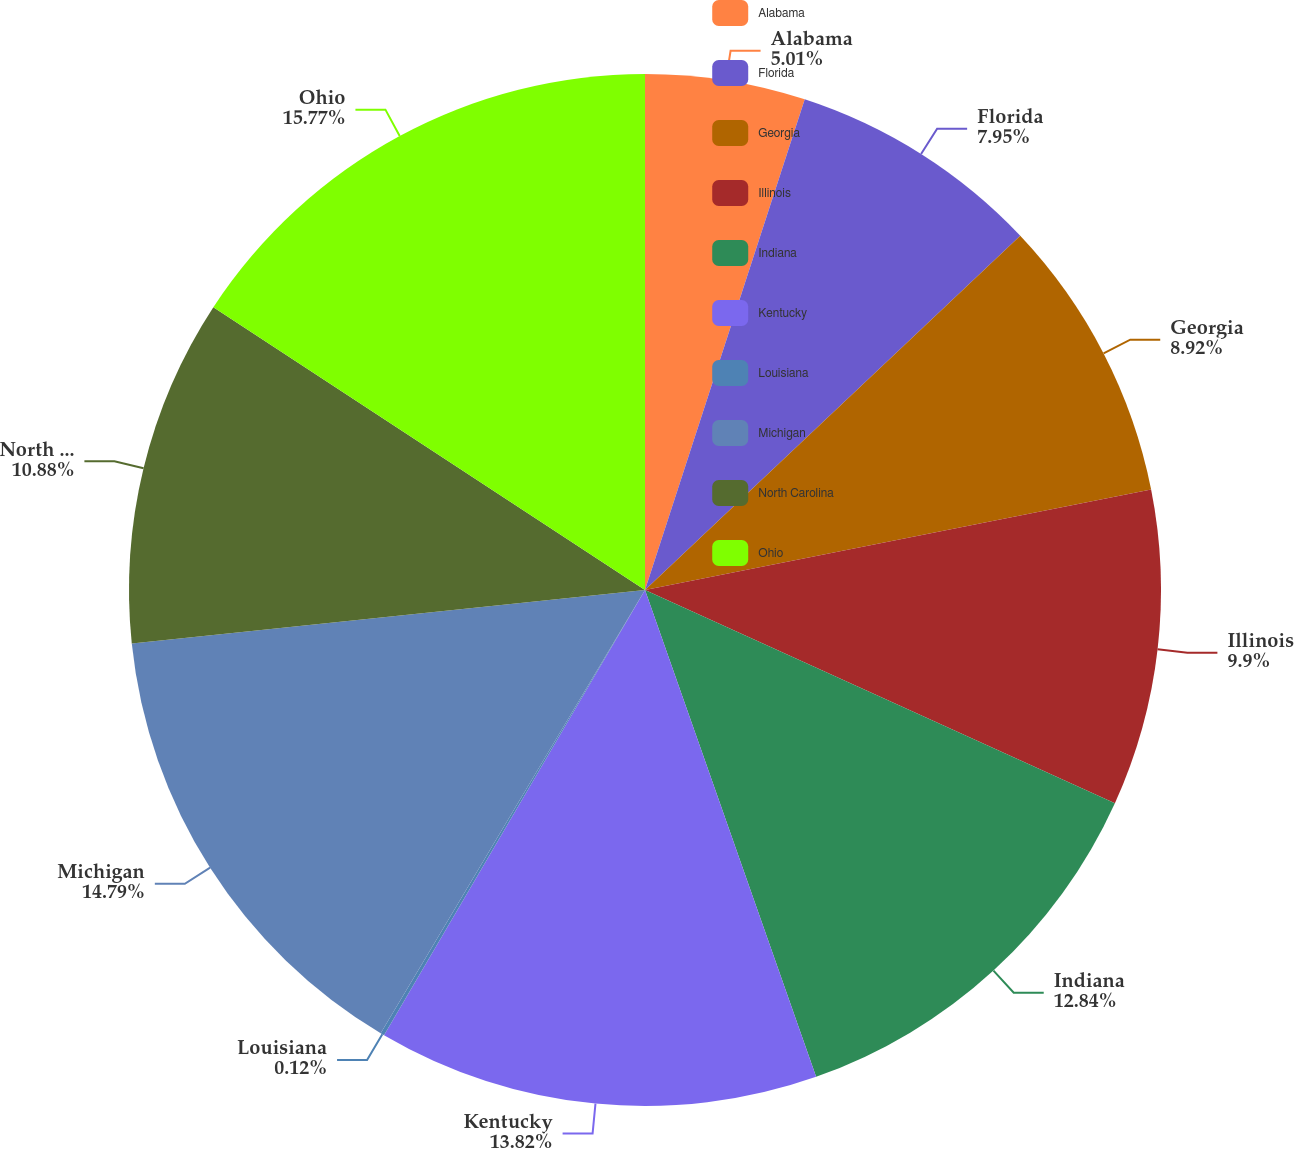Convert chart. <chart><loc_0><loc_0><loc_500><loc_500><pie_chart><fcel>Alabama<fcel>Florida<fcel>Georgia<fcel>Illinois<fcel>Indiana<fcel>Kentucky<fcel>Louisiana<fcel>Michigan<fcel>North Carolina<fcel>Ohio<nl><fcel>5.01%<fcel>7.95%<fcel>8.92%<fcel>9.9%<fcel>12.84%<fcel>13.82%<fcel>0.12%<fcel>14.79%<fcel>10.88%<fcel>15.77%<nl></chart> 